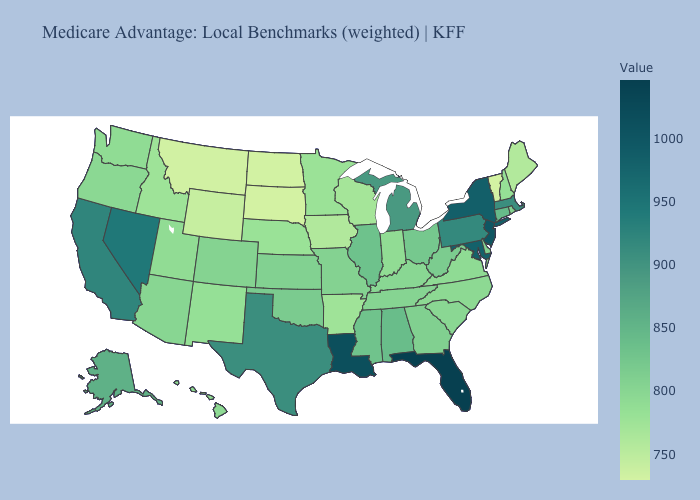Among the states that border Wyoming , which have the highest value?
Quick response, please. Colorado. Does Delaware have the highest value in the South?
Quick response, please. No. Does Colorado have the lowest value in the USA?
Quick response, please. No. Among the states that border Kentucky , which have the lowest value?
Keep it brief. Indiana. 